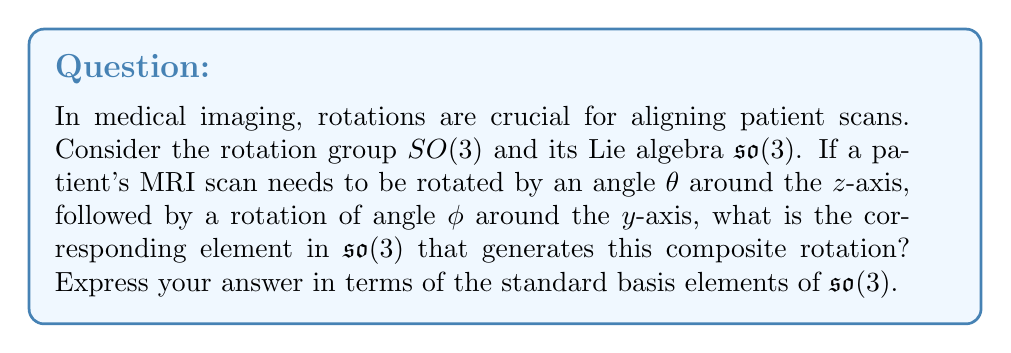Provide a solution to this math problem. To solve this problem, we need to follow these steps:

1) First, recall that the Lie algebra so(3) of SO(3) consists of 3x3 skew-symmetric matrices. The standard basis for so(3) is:

   $$L_x = \begin{pmatrix}0 & 0 & 0\\ 0 & 0 & -1\\ 0 & 1 & 0\end{pmatrix},
     L_y = \begin{pmatrix}0 & 0 & 1\\ 0 & 0 & 0\\ -1 & 0 & 0\end{pmatrix},
     L_z = \begin{pmatrix}0 & -1 & 0\\ 1 & 0 & 0\\ 0 & 0 & 0\end{pmatrix}$$

2) A rotation by angle $\theta$ around the z-axis is generated by $\theta L_z$.

3) A rotation by angle $\phi$ around the y-axis is generated by $\phi L_y$.

4) In Lie theory, the Baker-Campbell-Hausdorff formula gives us a way to compose rotations. For small rotations, we can approximate the composition by simply adding the generators.

5) Therefore, the composite rotation is approximately generated by:

   $$\theta L_z + \phi L_y$$

6) Substituting the matrices:

   $$\theta \begin{pmatrix}0 & -1 & 0\\ 1 & 0 & 0\\ 0 & 0 & 0\end{pmatrix} +
     \phi \begin{pmatrix}0 & 0 & 1\\ 0 & 0 & 0\\ -1 & 0 & 0\end{pmatrix}$$

7) Simplifying:

   $$\begin{pmatrix}0 & -\theta & \phi\\ \theta & 0 & 0\\ -\phi & 0 & 0\end{pmatrix}$$

This matrix in so(3) generates the desired composite rotation, which can be used to align the patient's MRI scan in the required orientation.
Answer: The element in so(3) that generates the composite rotation is $\theta L_z + \phi L_y$, or in matrix form:

$$\begin{pmatrix}0 & -\theta & \phi\\ \theta & 0 & 0\\ -\phi & 0 & 0\end{pmatrix}$$ 